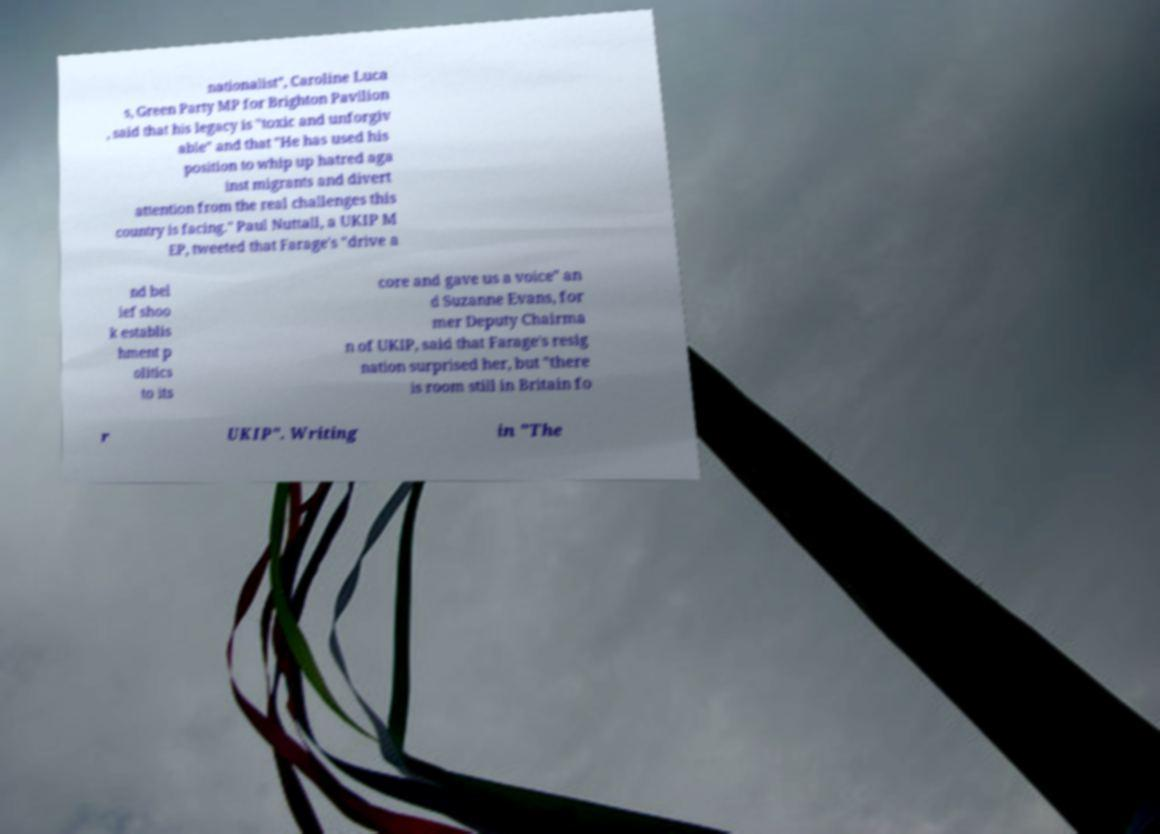Could you extract and type out the text from this image? nationalist", Caroline Luca s, Green Party MP for Brighton Pavilion , said that his legacy is "toxic and unforgiv able" and that "He has used his position to whip up hatred aga inst migrants and divert attention from the real challenges this country is facing." Paul Nuttall, a UKIP M EP, tweeted that Farage's "drive a nd bel ief shoo k establis hment p olitics to its core and gave us a voice" an d Suzanne Evans, for mer Deputy Chairma n of UKIP, said that Farage's resig nation surprised her, but "there is room still in Britain fo r UKIP". Writing in "The 